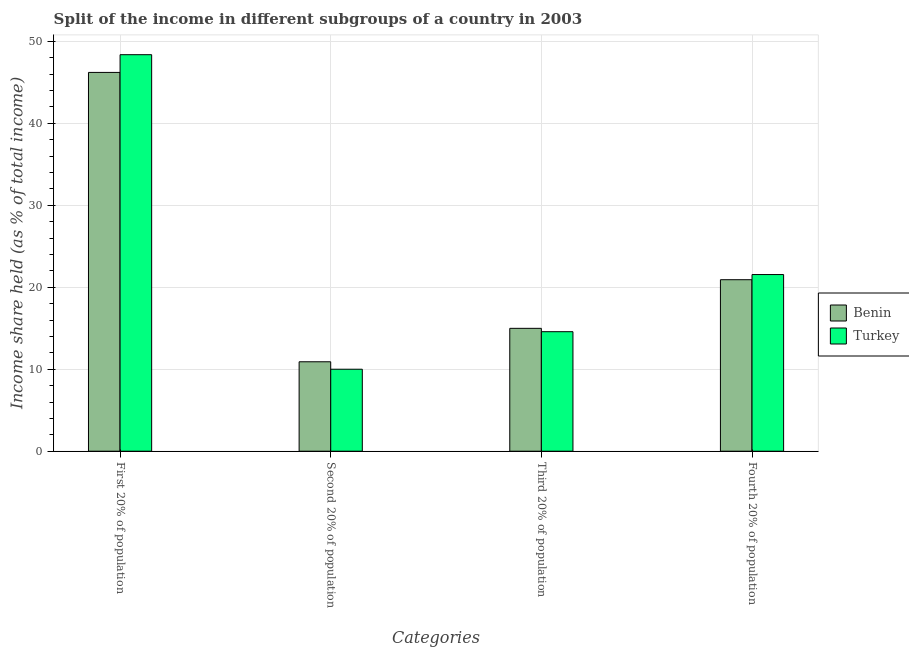How many groups of bars are there?
Provide a short and direct response. 4. Are the number of bars on each tick of the X-axis equal?
Offer a very short reply. Yes. How many bars are there on the 1st tick from the left?
Provide a succinct answer. 2. What is the label of the 3rd group of bars from the left?
Ensure brevity in your answer.  Third 20% of population. What is the share of the income held by third 20% of the population in Turkey?
Your response must be concise. 14.58. Across all countries, what is the maximum share of the income held by fourth 20% of the population?
Offer a very short reply. 21.55. In which country was the share of the income held by first 20% of the population minimum?
Keep it short and to the point. Benin. What is the total share of the income held by second 20% of the population in the graph?
Ensure brevity in your answer.  20.91. What is the difference between the share of the income held by third 20% of the population in Benin and that in Turkey?
Your response must be concise. 0.41. What is the difference between the share of the income held by first 20% of the population in Turkey and the share of the income held by second 20% of the population in Benin?
Provide a short and direct response. 37.46. What is the average share of the income held by third 20% of the population per country?
Offer a terse response. 14.79. What is the difference between the share of the income held by third 20% of the population and share of the income held by fourth 20% of the population in Turkey?
Provide a short and direct response. -6.97. In how many countries, is the share of the income held by third 20% of the population greater than 20 %?
Your answer should be very brief. 0. What is the ratio of the share of the income held by second 20% of the population in Turkey to that in Benin?
Offer a terse response. 0.92. Is the difference between the share of the income held by second 20% of the population in Benin and Turkey greater than the difference between the share of the income held by third 20% of the population in Benin and Turkey?
Your answer should be very brief. Yes. What is the difference between the highest and the second highest share of the income held by third 20% of the population?
Your answer should be compact. 0.41. What is the difference between the highest and the lowest share of the income held by fourth 20% of the population?
Give a very brief answer. 0.63. Is the sum of the share of the income held by first 20% of the population in Benin and Turkey greater than the maximum share of the income held by third 20% of the population across all countries?
Keep it short and to the point. Yes. What does the 1st bar from the left in Fourth 20% of population represents?
Offer a terse response. Benin. What does the 2nd bar from the right in Second 20% of population represents?
Keep it short and to the point. Benin. Is it the case that in every country, the sum of the share of the income held by first 20% of the population and share of the income held by second 20% of the population is greater than the share of the income held by third 20% of the population?
Offer a very short reply. Yes. How many bars are there?
Ensure brevity in your answer.  8. How many countries are there in the graph?
Your answer should be compact. 2. Does the graph contain any zero values?
Offer a very short reply. No. Does the graph contain grids?
Offer a very short reply. Yes. How many legend labels are there?
Provide a succinct answer. 2. What is the title of the graph?
Provide a succinct answer. Split of the income in different subgroups of a country in 2003. Does "Venezuela" appear as one of the legend labels in the graph?
Offer a terse response. No. What is the label or title of the X-axis?
Your answer should be very brief. Categories. What is the label or title of the Y-axis?
Make the answer very short. Income share held (as % of total income). What is the Income share held (as % of total income) in Benin in First 20% of population?
Provide a short and direct response. 46.21. What is the Income share held (as % of total income) of Turkey in First 20% of population?
Your response must be concise. 48.37. What is the Income share held (as % of total income) of Benin in Second 20% of population?
Make the answer very short. 10.91. What is the Income share held (as % of total income) of Turkey in Second 20% of population?
Ensure brevity in your answer.  10. What is the Income share held (as % of total income) of Benin in Third 20% of population?
Offer a very short reply. 14.99. What is the Income share held (as % of total income) of Turkey in Third 20% of population?
Offer a very short reply. 14.58. What is the Income share held (as % of total income) of Benin in Fourth 20% of population?
Give a very brief answer. 20.92. What is the Income share held (as % of total income) in Turkey in Fourth 20% of population?
Offer a very short reply. 21.55. Across all Categories, what is the maximum Income share held (as % of total income) in Benin?
Provide a short and direct response. 46.21. Across all Categories, what is the maximum Income share held (as % of total income) in Turkey?
Ensure brevity in your answer.  48.37. Across all Categories, what is the minimum Income share held (as % of total income) of Benin?
Ensure brevity in your answer.  10.91. What is the total Income share held (as % of total income) of Benin in the graph?
Provide a short and direct response. 93.03. What is the total Income share held (as % of total income) in Turkey in the graph?
Offer a very short reply. 94.5. What is the difference between the Income share held (as % of total income) in Benin in First 20% of population and that in Second 20% of population?
Your answer should be very brief. 35.3. What is the difference between the Income share held (as % of total income) in Turkey in First 20% of population and that in Second 20% of population?
Give a very brief answer. 38.37. What is the difference between the Income share held (as % of total income) of Benin in First 20% of population and that in Third 20% of population?
Offer a very short reply. 31.22. What is the difference between the Income share held (as % of total income) in Turkey in First 20% of population and that in Third 20% of population?
Keep it short and to the point. 33.79. What is the difference between the Income share held (as % of total income) in Benin in First 20% of population and that in Fourth 20% of population?
Make the answer very short. 25.29. What is the difference between the Income share held (as % of total income) of Turkey in First 20% of population and that in Fourth 20% of population?
Offer a terse response. 26.82. What is the difference between the Income share held (as % of total income) of Benin in Second 20% of population and that in Third 20% of population?
Provide a short and direct response. -4.08. What is the difference between the Income share held (as % of total income) in Turkey in Second 20% of population and that in Third 20% of population?
Provide a succinct answer. -4.58. What is the difference between the Income share held (as % of total income) in Benin in Second 20% of population and that in Fourth 20% of population?
Your response must be concise. -10.01. What is the difference between the Income share held (as % of total income) of Turkey in Second 20% of population and that in Fourth 20% of population?
Give a very brief answer. -11.55. What is the difference between the Income share held (as % of total income) of Benin in Third 20% of population and that in Fourth 20% of population?
Keep it short and to the point. -5.93. What is the difference between the Income share held (as % of total income) in Turkey in Third 20% of population and that in Fourth 20% of population?
Ensure brevity in your answer.  -6.97. What is the difference between the Income share held (as % of total income) of Benin in First 20% of population and the Income share held (as % of total income) of Turkey in Second 20% of population?
Ensure brevity in your answer.  36.21. What is the difference between the Income share held (as % of total income) in Benin in First 20% of population and the Income share held (as % of total income) in Turkey in Third 20% of population?
Ensure brevity in your answer.  31.63. What is the difference between the Income share held (as % of total income) of Benin in First 20% of population and the Income share held (as % of total income) of Turkey in Fourth 20% of population?
Offer a terse response. 24.66. What is the difference between the Income share held (as % of total income) in Benin in Second 20% of population and the Income share held (as % of total income) in Turkey in Third 20% of population?
Your answer should be very brief. -3.67. What is the difference between the Income share held (as % of total income) in Benin in Second 20% of population and the Income share held (as % of total income) in Turkey in Fourth 20% of population?
Keep it short and to the point. -10.64. What is the difference between the Income share held (as % of total income) of Benin in Third 20% of population and the Income share held (as % of total income) of Turkey in Fourth 20% of population?
Offer a terse response. -6.56. What is the average Income share held (as % of total income) in Benin per Categories?
Ensure brevity in your answer.  23.26. What is the average Income share held (as % of total income) in Turkey per Categories?
Ensure brevity in your answer.  23.62. What is the difference between the Income share held (as % of total income) of Benin and Income share held (as % of total income) of Turkey in First 20% of population?
Offer a very short reply. -2.16. What is the difference between the Income share held (as % of total income) of Benin and Income share held (as % of total income) of Turkey in Second 20% of population?
Your response must be concise. 0.91. What is the difference between the Income share held (as % of total income) of Benin and Income share held (as % of total income) of Turkey in Third 20% of population?
Provide a succinct answer. 0.41. What is the difference between the Income share held (as % of total income) of Benin and Income share held (as % of total income) of Turkey in Fourth 20% of population?
Make the answer very short. -0.63. What is the ratio of the Income share held (as % of total income) in Benin in First 20% of population to that in Second 20% of population?
Give a very brief answer. 4.24. What is the ratio of the Income share held (as % of total income) of Turkey in First 20% of population to that in Second 20% of population?
Give a very brief answer. 4.84. What is the ratio of the Income share held (as % of total income) in Benin in First 20% of population to that in Third 20% of population?
Your answer should be very brief. 3.08. What is the ratio of the Income share held (as % of total income) in Turkey in First 20% of population to that in Third 20% of population?
Ensure brevity in your answer.  3.32. What is the ratio of the Income share held (as % of total income) of Benin in First 20% of population to that in Fourth 20% of population?
Your answer should be compact. 2.21. What is the ratio of the Income share held (as % of total income) in Turkey in First 20% of population to that in Fourth 20% of population?
Provide a short and direct response. 2.24. What is the ratio of the Income share held (as % of total income) in Benin in Second 20% of population to that in Third 20% of population?
Ensure brevity in your answer.  0.73. What is the ratio of the Income share held (as % of total income) in Turkey in Second 20% of population to that in Third 20% of population?
Make the answer very short. 0.69. What is the ratio of the Income share held (as % of total income) of Benin in Second 20% of population to that in Fourth 20% of population?
Keep it short and to the point. 0.52. What is the ratio of the Income share held (as % of total income) in Turkey in Second 20% of population to that in Fourth 20% of population?
Give a very brief answer. 0.46. What is the ratio of the Income share held (as % of total income) in Benin in Third 20% of population to that in Fourth 20% of population?
Your response must be concise. 0.72. What is the ratio of the Income share held (as % of total income) of Turkey in Third 20% of population to that in Fourth 20% of population?
Your answer should be very brief. 0.68. What is the difference between the highest and the second highest Income share held (as % of total income) in Benin?
Your response must be concise. 25.29. What is the difference between the highest and the second highest Income share held (as % of total income) of Turkey?
Offer a very short reply. 26.82. What is the difference between the highest and the lowest Income share held (as % of total income) of Benin?
Ensure brevity in your answer.  35.3. What is the difference between the highest and the lowest Income share held (as % of total income) of Turkey?
Provide a succinct answer. 38.37. 